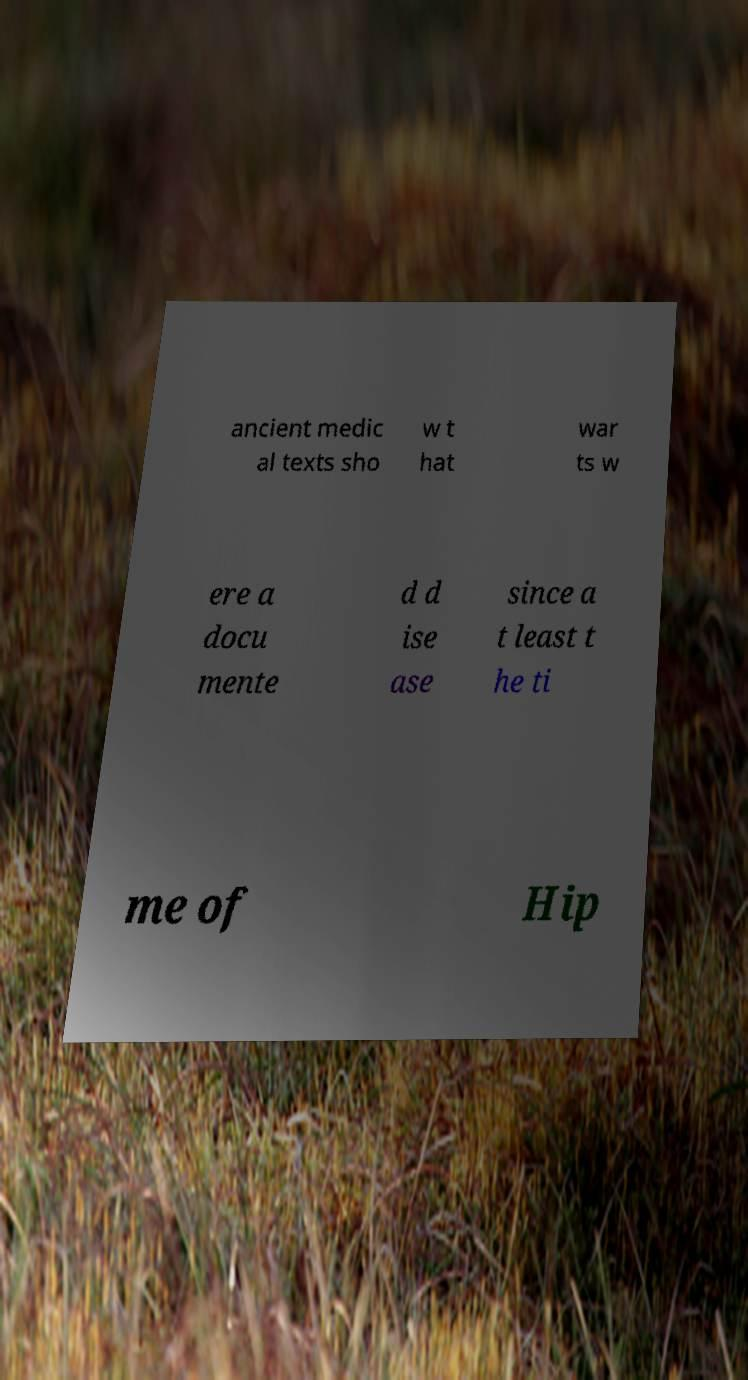Please identify and transcribe the text found in this image. ancient medic al texts sho w t hat war ts w ere a docu mente d d ise ase since a t least t he ti me of Hip 